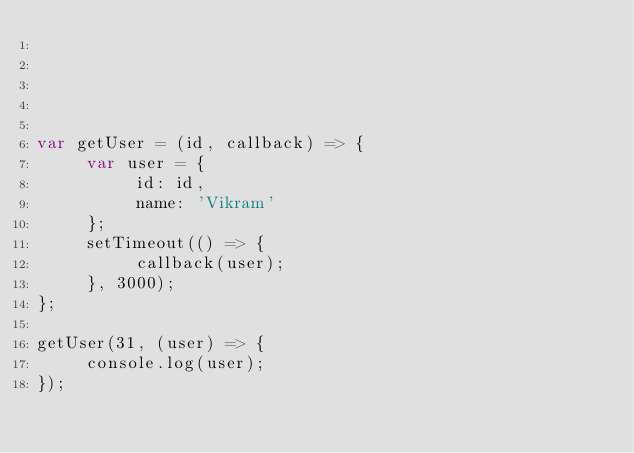Convert code to text. <code><loc_0><loc_0><loc_500><loc_500><_JavaScript_>




var getUser = (id, callback) => {
     var user = {
          id: id,
          name: 'Vikram'
     };
     setTimeout(() => {
          callback(user);
     }, 3000);    
};

getUser(31, (user) => {
     console.log(user);
});</code> 